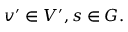Convert formula to latex. <formula><loc_0><loc_0><loc_500><loc_500>v ^ { \prime } \in V ^ { \prime } , s \in G .</formula> 